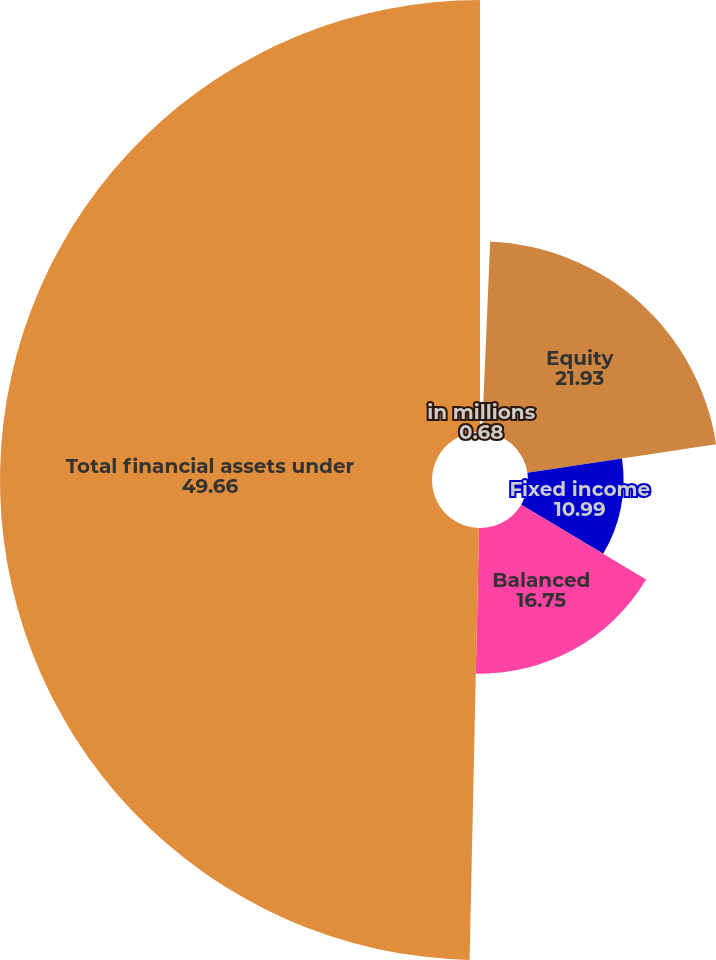<chart> <loc_0><loc_0><loc_500><loc_500><pie_chart><fcel>in millions<fcel>Equity<fcel>Fixed income<fcel>Balanced<fcel>Total financial assets under<nl><fcel>0.68%<fcel>21.93%<fcel>10.99%<fcel>16.75%<fcel>49.66%<nl></chart> 